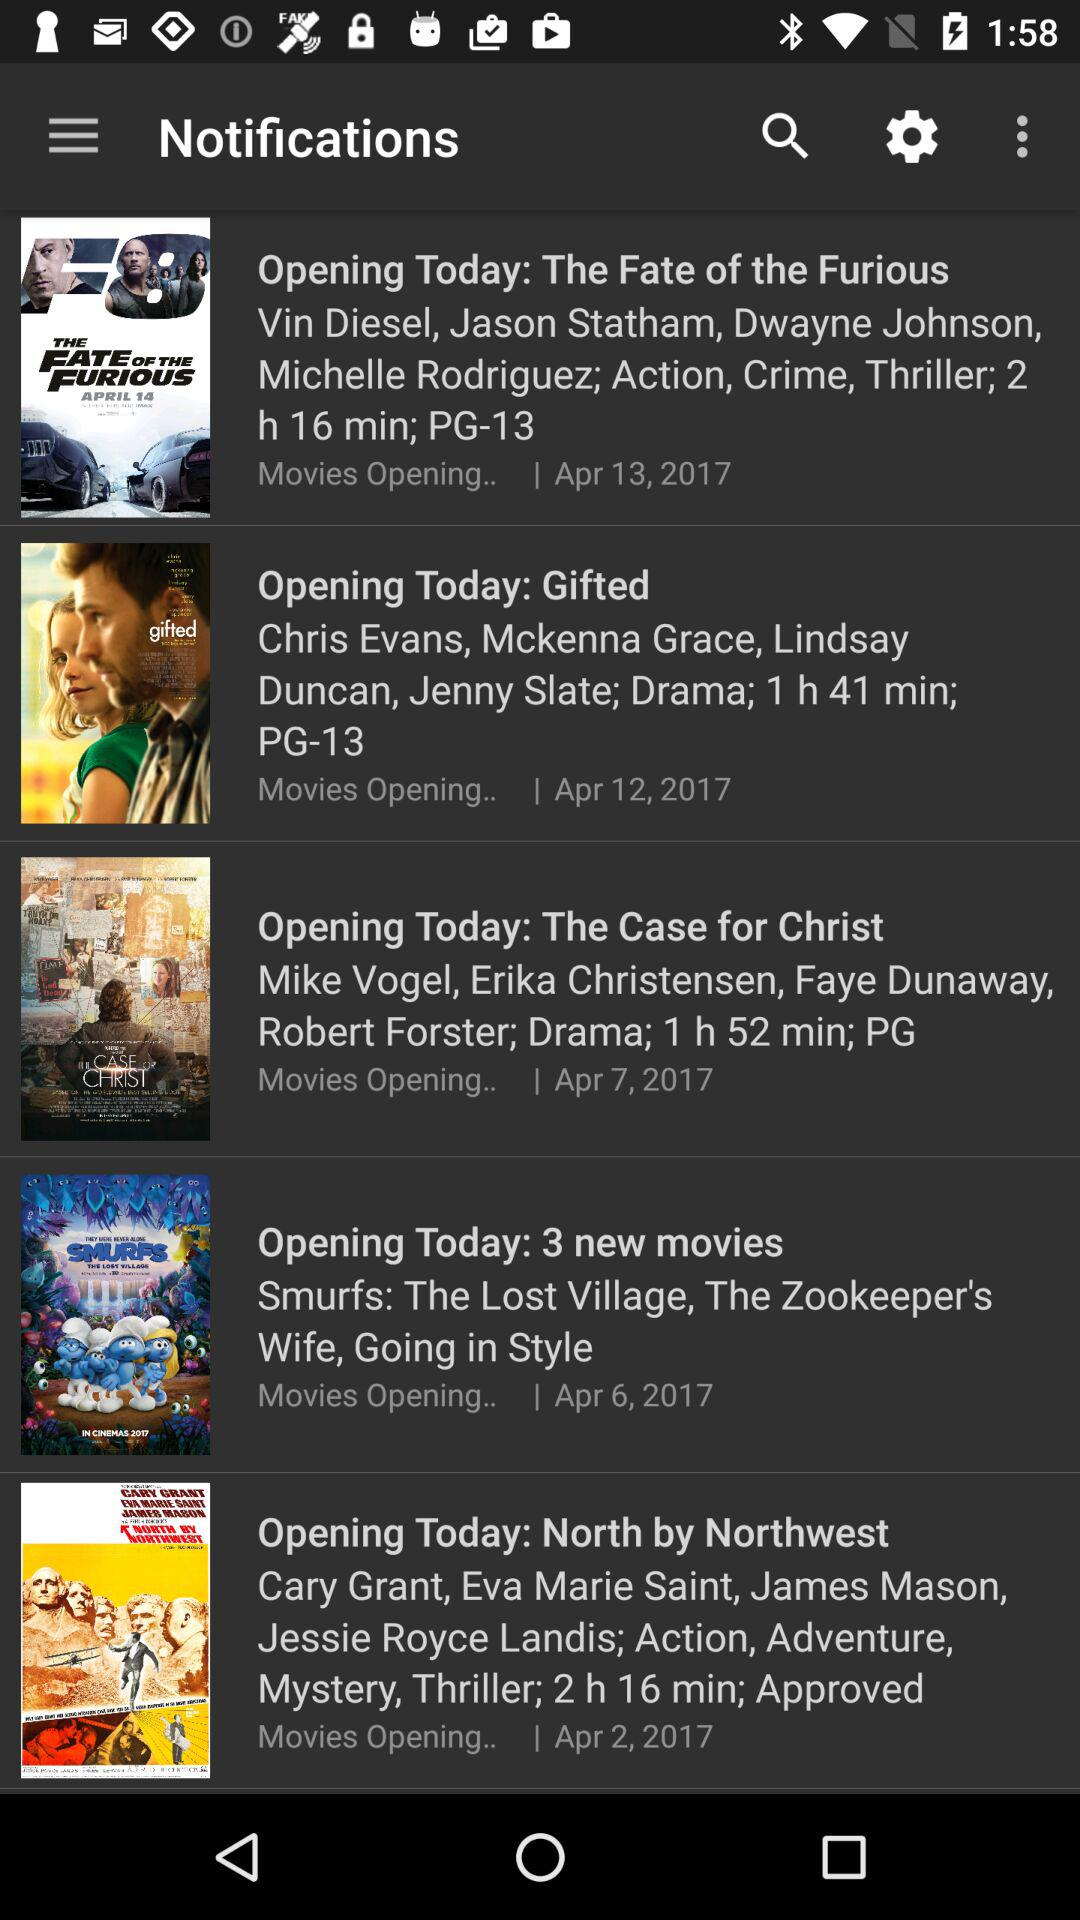What is the duration of the "The Case for Christ" movie? The duration of the "The Case for Christ" movie is 1 hour 52 minutes. 